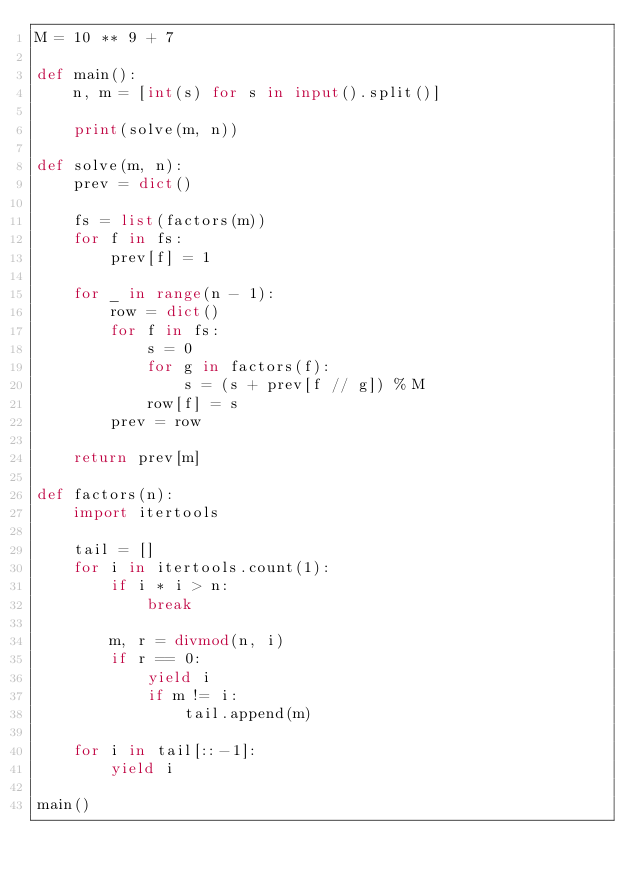Convert code to text. <code><loc_0><loc_0><loc_500><loc_500><_Python_>M = 10 ** 9 + 7

def main():
    n, m = [int(s) for s in input().split()]

    print(solve(m, n))

def solve(m, n):
    prev = dict()

    fs = list(factors(m))
    for f in fs:
        prev[f] = 1

    for _ in range(n - 1):
        row = dict()
        for f in fs:
            s = 0
            for g in factors(f):
                s = (s + prev[f // g]) % M
            row[f] = s
        prev = row

    return prev[m]

def factors(n):
    import itertools

    tail = []
    for i in itertools.count(1):
        if i * i > n:
            break

        m, r = divmod(n, i)
        if r == 0:
            yield i
            if m != i:
                tail.append(m)
    
    for i in tail[::-1]:
        yield i

main()
</code> 